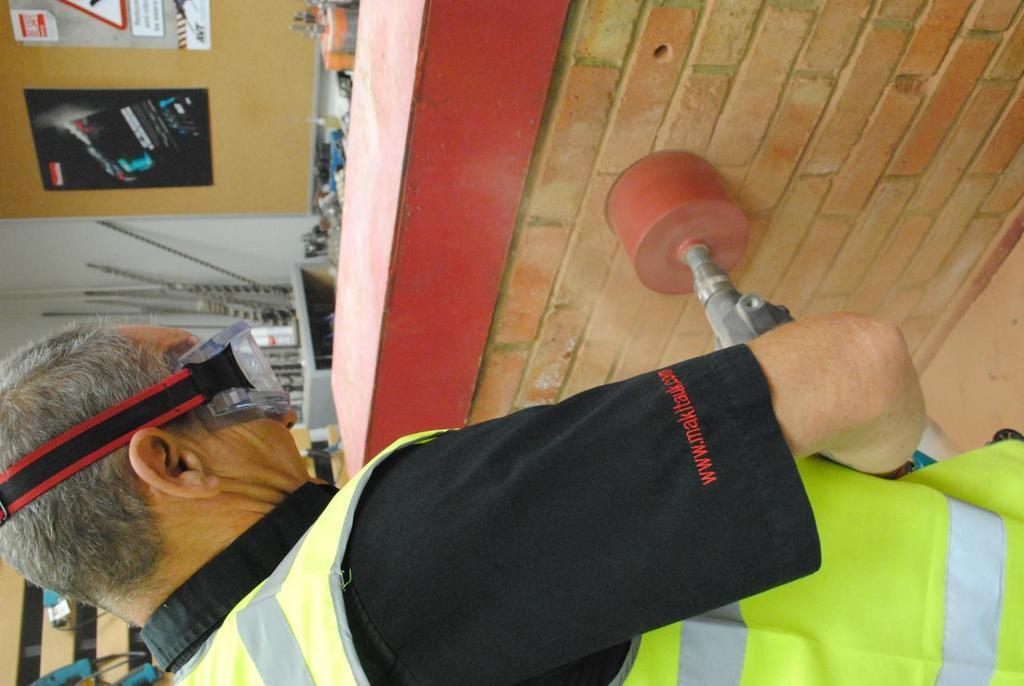Who is present in the image? There is a man in the image. What is the man doing in the image? The man is standing and drilling a hole. What tool is the man using to drill the hole? The man is holding a drilling machine. What is the background of the image? There is a wall in the image. How many trucks are parked near the man in the image? There are no trucks present in the image. What time of day is it in the image? The time of day cannot be determined from the image. 